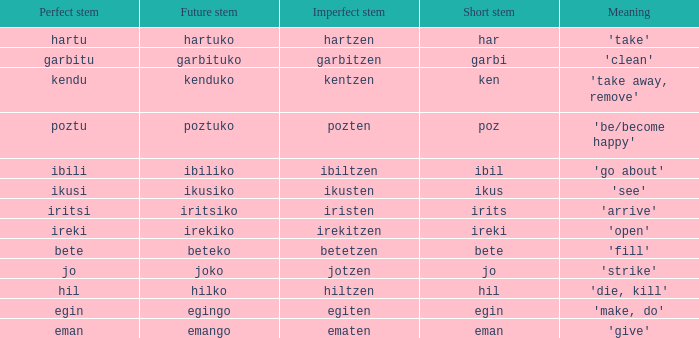What is the impeccable base for pozten? Poztu. 